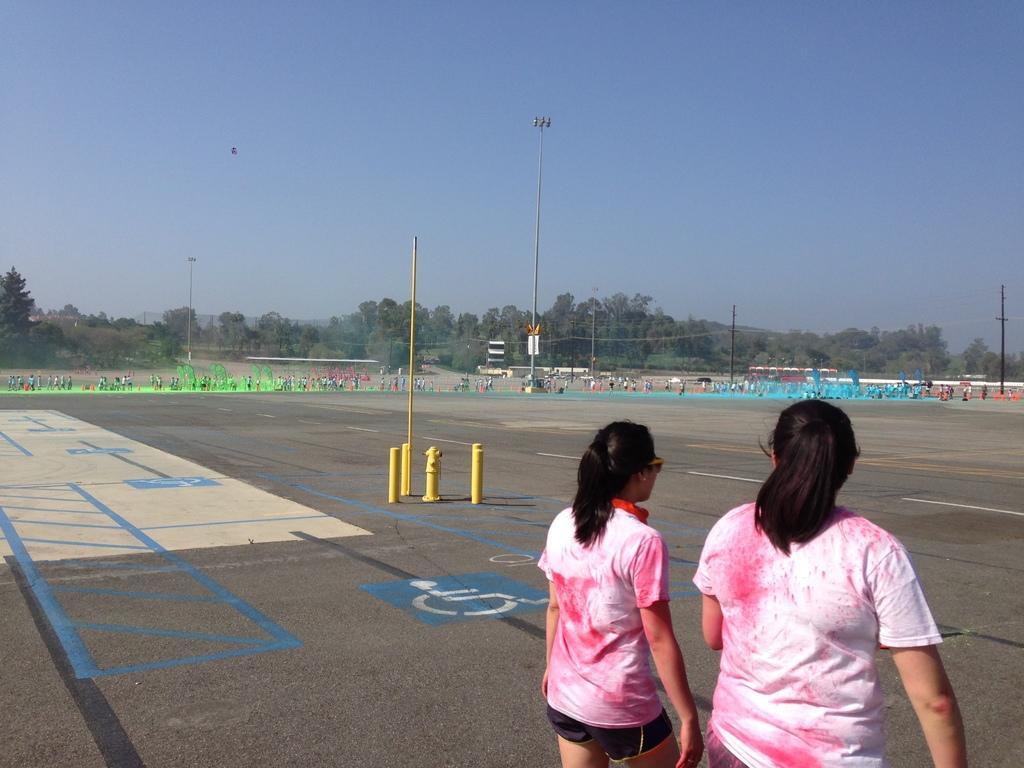How would you summarize this image in a sentence or two? In this image I can see 2 people standing. There are poles, wires and trees at the back. There is sky at the top. 